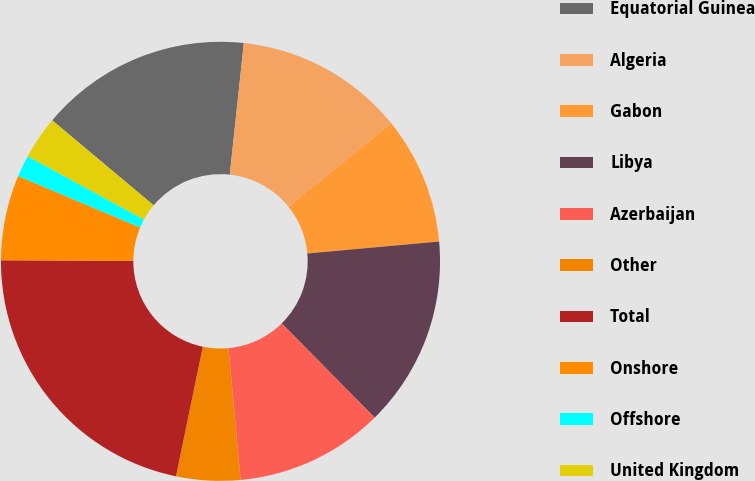Convert chart. <chart><loc_0><loc_0><loc_500><loc_500><pie_chart><fcel>Equatorial Guinea<fcel>Algeria<fcel>Gabon<fcel>Libya<fcel>Azerbaijan<fcel>Other<fcel>Total<fcel>Onshore<fcel>Offshore<fcel>United Kingdom<nl><fcel>15.6%<fcel>12.49%<fcel>9.38%<fcel>14.05%<fcel>10.93%<fcel>4.71%<fcel>21.83%<fcel>6.27%<fcel>1.6%<fcel>3.15%<nl></chart> 